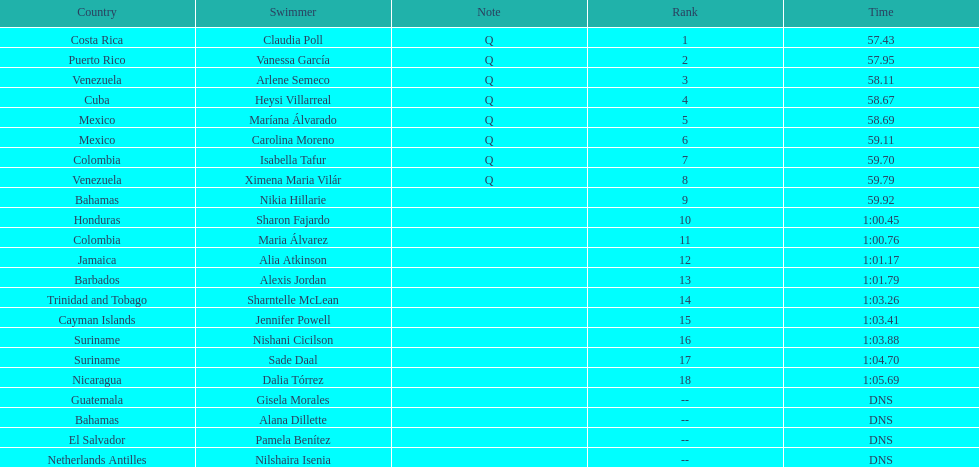How many mexican swimmers ranked in the top 10? 2. 